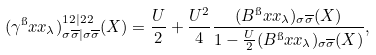Convert formula to latex. <formula><loc_0><loc_0><loc_500><loc_500>( \gamma ^ { \i } x { x } _ { \lambda } ) ^ { 1 2 | 2 2 } _ { \sigma \overline { \sigma } | \sigma \overline { \sigma } } ( X ) = \frac { U } { 2 } + \frac { U ^ { 2 } } { 4 } \frac { ( B ^ { \i } x { x } _ { \lambda } ) _ { \sigma \overline { \sigma } } ( X ) } { 1 - \frac { U } { 2 } ( B ^ { \i } x { x } _ { \lambda } ) _ { \sigma \overline { \sigma } } ( X ) } ,</formula> 